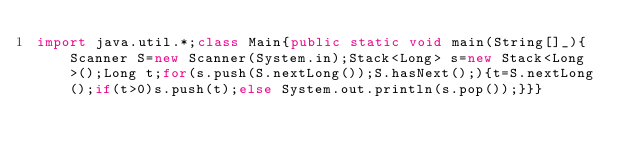<code> <loc_0><loc_0><loc_500><loc_500><_Java_>import java.util.*;class Main{public static void main(String[]_){Scanner S=new Scanner(System.in);Stack<Long> s=new Stack<Long>();Long t;for(s.push(S.nextLong());S.hasNext();){t=S.nextLong();if(t>0)s.push(t);else System.out.println(s.pop());}}}</code> 